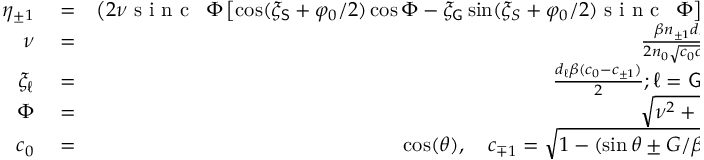<formula> <loc_0><loc_0><loc_500><loc_500>\begin{array} { r l r } { \eta _ { \pm 1 } } & = } & { \left ( 2 \nu \sin c \, { \Phi } \left [ \cos ( \xi _ { S } + \varphi _ { 0 } / 2 ) \cos \Phi - \xi _ { G } \sin ( \xi _ { S } + \varphi _ { 0 } / 2 ) \sin c \, { \Phi } \right ] \right ) ^ { 2 } } \\ { \nu } & = } & { \frac { \beta n _ { \pm 1 } d _ { G } } { 2 n _ { 0 } \sqrt { c _ { 0 } c _ { \pm 1 } } } } \\ { \xi _ { \ell } } & = } & { \frac { d _ { \ell } \beta ( c _ { 0 } - c _ { \pm 1 } ) } { 2 } ; \ell = G , S } \\ { \Phi } & = } & { \sqrt { \nu ^ { 2 } + \xi _ { G } ^ { 2 } } } \\ { c _ { 0 } } & = } & { \cos ( \theta ) , \quad c _ { \mp 1 } = \sqrt { 1 - ( \sin \theta \pm G / \beta ) ^ { 2 } } } \end{array}</formula> 